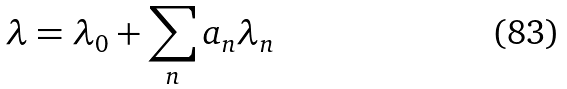Convert formula to latex. <formula><loc_0><loc_0><loc_500><loc_500>\lambda = \lambda _ { 0 } + \sum _ { n } a _ { n } \lambda _ { n }</formula> 